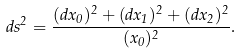Convert formula to latex. <formula><loc_0><loc_0><loc_500><loc_500>d s ^ { 2 } = \frac { ( d x _ { 0 } ) ^ { 2 } + ( d x _ { 1 } ) ^ { 2 } + ( d x _ { 2 } ) ^ { 2 } } { ( x _ { 0 } ) ^ { 2 } } .</formula> 